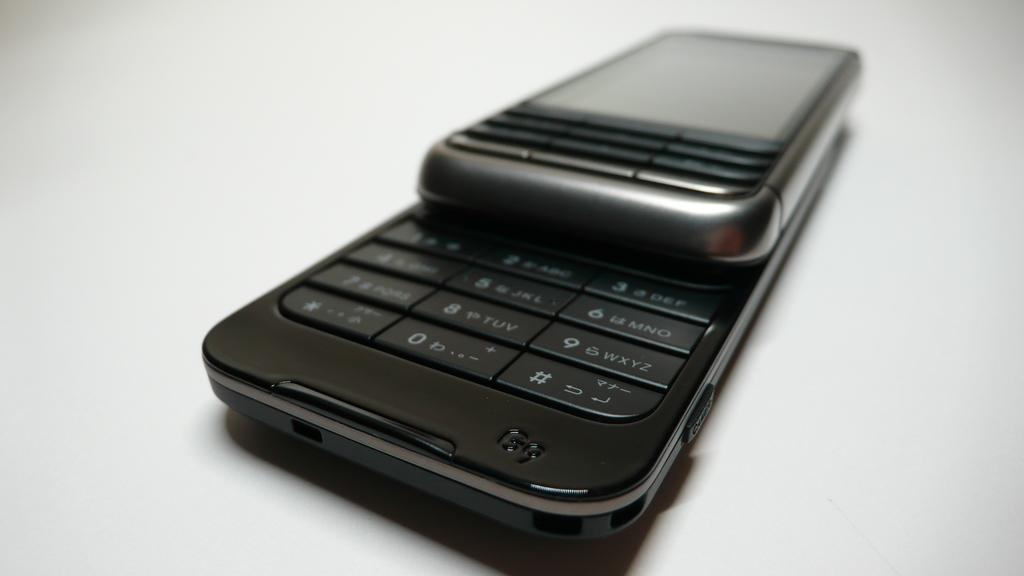Provide a one-sentence caption for the provided image. a black and silver, slide cell phone with G9 in the lower corner is laying on a table. 